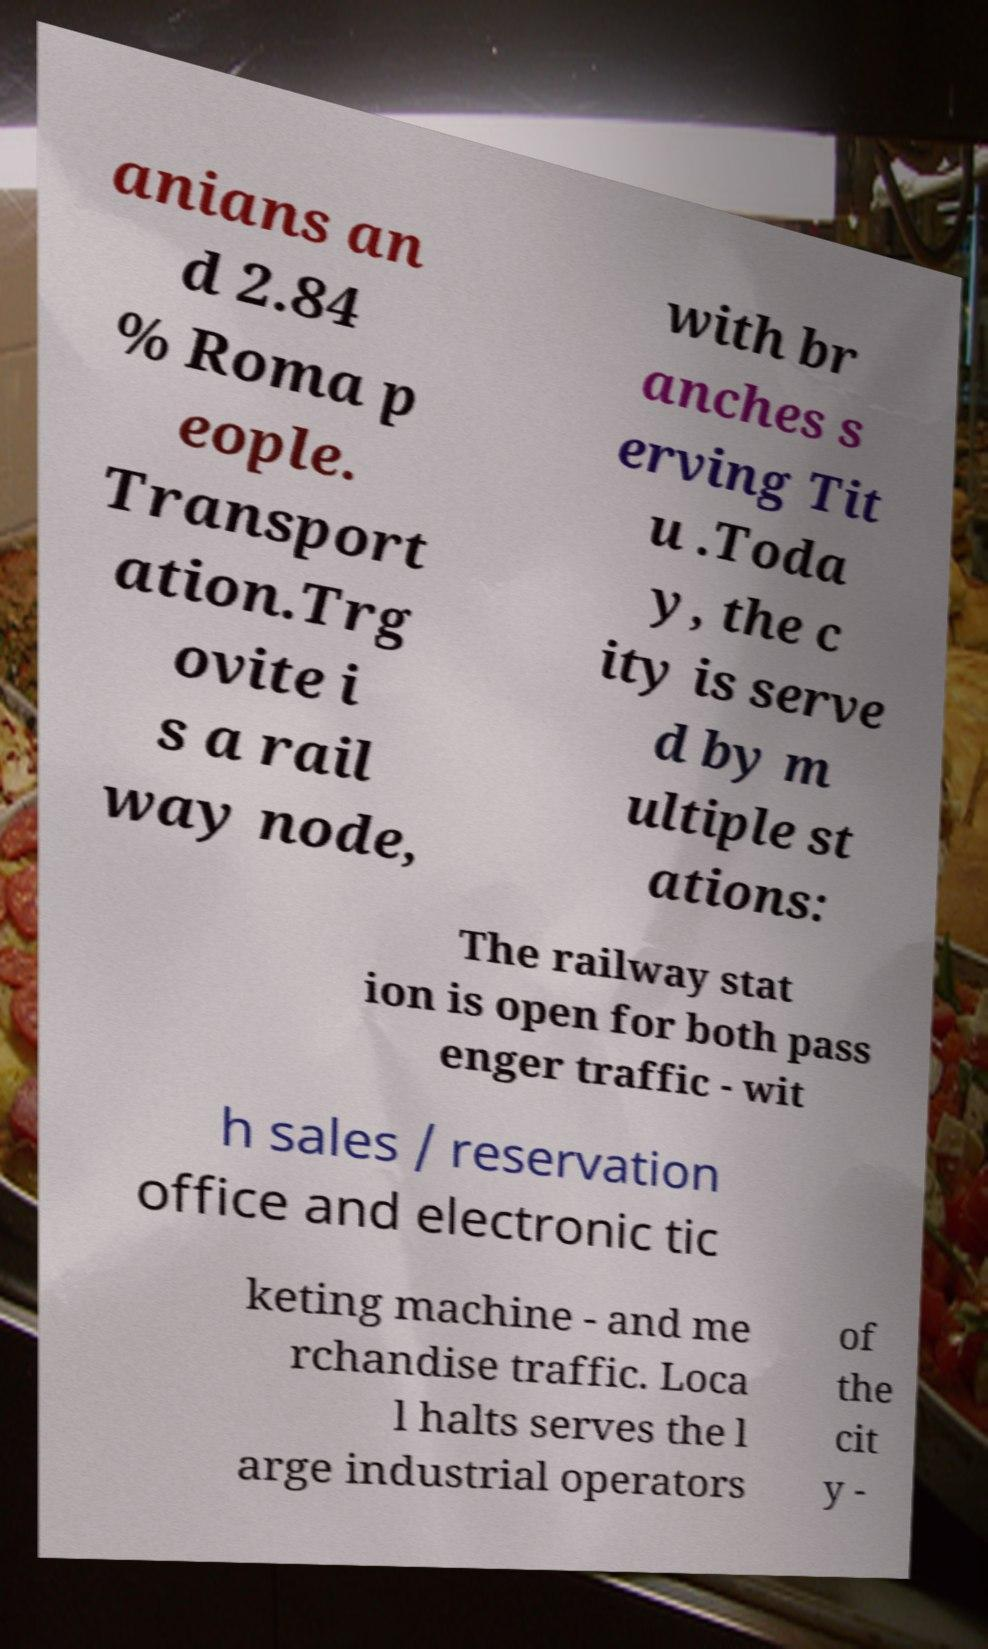Can you accurately transcribe the text from the provided image for me? anians an d 2.84 % Roma p eople. Transport ation.Trg ovite i s a rail way node, with br anches s erving Tit u .Toda y, the c ity is serve d by m ultiple st ations: The railway stat ion is open for both pass enger traffic - wit h sales / reservation office and electronic tic keting machine - and me rchandise traffic. Loca l halts serves the l arge industrial operators of the cit y - 